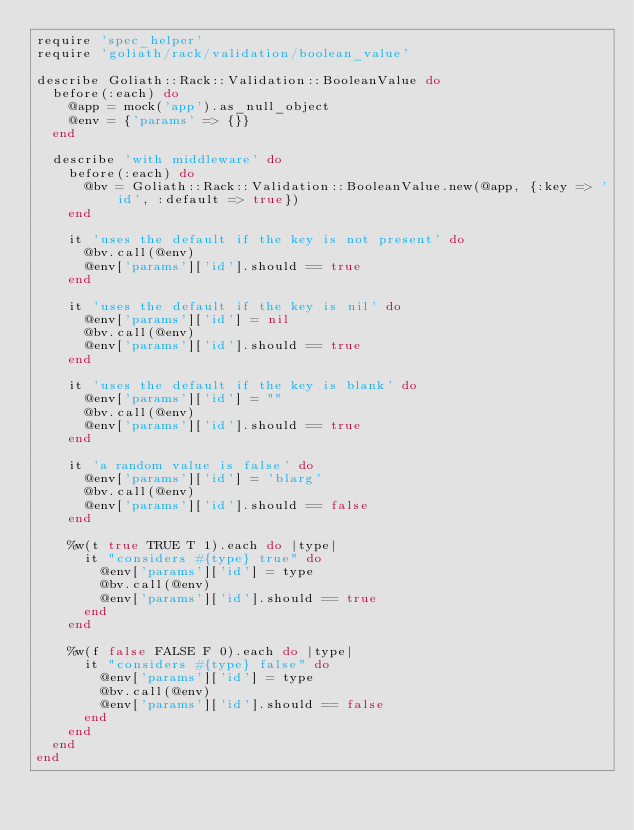Convert code to text. <code><loc_0><loc_0><loc_500><loc_500><_Ruby_>require 'spec_helper'
require 'goliath/rack/validation/boolean_value'

describe Goliath::Rack::Validation::BooleanValue do
  before(:each) do
    @app = mock('app').as_null_object
    @env = {'params' => {}}
  end

  describe 'with middleware' do
    before(:each) do
      @bv = Goliath::Rack::Validation::BooleanValue.new(@app, {:key => 'id', :default => true})
    end

    it 'uses the default if the key is not present' do
      @bv.call(@env)
      @env['params']['id'].should == true
    end

    it 'uses the default if the key is nil' do
      @env['params']['id'] = nil
      @bv.call(@env)
      @env['params']['id'].should == true
    end

    it 'uses the default if the key is blank' do
      @env['params']['id'] = ""
      @bv.call(@env)
      @env['params']['id'].should == true
    end

    it 'a random value is false' do
      @env['params']['id'] = 'blarg'
      @bv.call(@env)
      @env['params']['id'].should == false
    end

    %w(t true TRUE T 1).each do |type|
      it "considers #{type} true" do
        @env['params']['id'] = type
        @bv.call(@env)
        @env['params']['id'].should == true
      end
    end

    %w(f false FALSE F 0).each do |type|
      it "considers #{type} false" do
        @env['params']['id'] = type
        @bv.call(@env)
        @env['params']['id'].should == false
      end
    end
  end
end</code> 